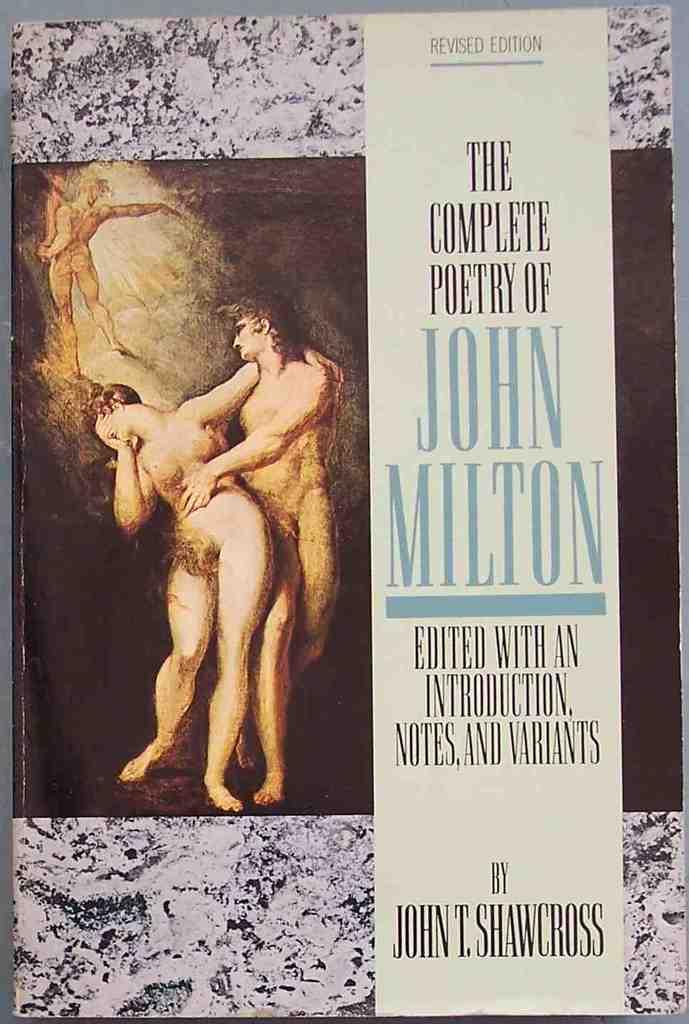Who is the author?
Offer a terse response. John t. shawcross. What is the title of the book?
Provide a succinct answer. The complete poetry of john milton. 